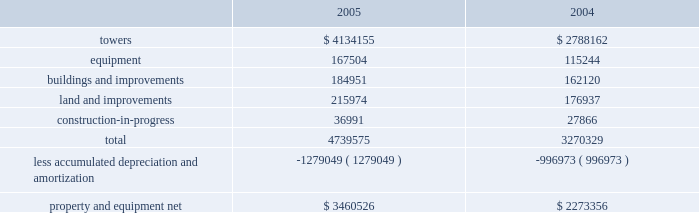American tower corporation and subsidiaries notes to consolidated financial statements 2014 ( continued ) operations , net , in the accompanying consolidated statements of operations for the year ended december 31 , 2003 .
( see note 9. ) other transactions 2014in august 2003 , the company consummated the sale of galaxy engineering ( galaxy ) , a radio frequency engineering , network design and tower-related consulting business ( previously included in the company 2019s network development services segment ) .
The purchase price of approximately $ 3.5 million included $ 2.0 million in cash , which the company received at closing , and an additional $ 1.5 million payable on january 15 , 2008 , or at an earlier date based on the future revenues of galaxy .
The company received $ 0.5 million of this amount in january 2005 .
Pursuant to this transaction , the company recorded a net loss on disposal of approximately $ 2.4 million in the accompanying consolidated statement of operations for the year ended december 31 , 2003 .
In may 2003 , the company consummated the sale of an office building in westwood , massachusetts ( previously held primarily as rental property and included in the company 2019s rental and management segment ) for a purchase price of approximately $ 18.5 million , including $ 2.4 million of cash proceeds and the buyer 2019s assumption of $ 16.1 million of related mortgage notes .
Pursuant to this transaction , the company recorded a net loss on disposal of approximately $ 3.6 million in the accompanying consolidated statement of operations for the year ended december 31 , 2003 .
In january 2003 , the company consummated the sale of flash technologies , its remaining components business ( previously included in the company 2019s network development services segment ) for approximately $ 35.5 million in cash and has recorded a net gain on disposal of approximately $ 0.1 million in the accompanying consolidated statement of operations for the year ended december 31 , 2003 .
In march 2003 , the company consummated the sale of an office building in schaumburg , illinois ( previously held primarily as rental property and included in the company 2019s rental and management segment ) for net proceeds of approximately $ 10.3 million in cash and recorded a net loss on disposal of $ 0.1 million in the accompanying consolidated statement of operations for the year ended december 31 , 2003 .
Property and equipment property and equipment ( including assets held under capital leases ) consist of the following as of december 31 , ( in thousands ) : .
Goodwill and other intangible assets the company 2019s net carrying amount of goodwill was approximately $ 2.1 billion as of december 312005 and $ 592.7 million as of december 31 , 2004 , all of which related to its rental and management segment .
The increase in the carrying value was as a result of the goodwill of $ 1.5 billion acquired in the merger with spectrasite , inc .
( see note 2. ) .
What is the percentage change in the balance of total property and equipment from 2004 to 2005? 
Computations: ((4739575 - 3270329) / 3270329)
Answer: 0.44927. American tower corporation and subsidiaries notes to consolidated financial statements 2014 ( continued ) operations , net , in the accompanying consolidated statements of operations for the year ended december 31 , 2003 .
( see note 9. ) other transactions 2014in august 2003 , the company consummated the sale of galaxy engineering ( galaxy ) , a radio frequency engineering , network design and tower-related consulting business ( previously included in the company 2019s network development services segment ) .
The purchase price of approximately $ 3.5 million included $ 2.0 million in cash , which the company received at closing , and an additional $ 1.5 million payable on january 15 , 2008 , or at an earlier date based on the future revenues of galaxy .
The company received $ 0.5 million of this amount in january 2005 .
Pursuant to this transaction , the company recorded a net loss on disposal of approximately $ 2.4 million in the accompanying consolidated statement of operations for the year ended december 31 , 2003 .
In may 2003 , the company consummated the sale of an office building in westwood , massachusetts ( previously held primarily as rental property and included in the company 2019s rental and management segment ) for a purchase price of approximately $ 18.5 million , including $ 2.4 million of cash proceeds and the buyer 2019s assumption of $ 16.1 million of related mortgage notes .
Pursuant to this transaction , the company recorded a net loss on disposal of approximately $ 3.6 million in the accompanying consolidated statement of operations for the year ended december 31 , 2003 .
In january 2003 , the company consummated the sale of flash technologies , its remaining components business ( previously included in the company 2019s network development services segment ) for approximately $ 35.5 million in cash and has recorded a net gain on disposal of approximately $ 0.1 million in the accompanying consolidated statement of operations for the year ended december 31 , 2003 .
In march 2003 , the company consummated the sale of an office building in schaumburg , illinois ( previously held primarily as rental property and included in the company 2019s rental and management segment ) for net proceeds of approximately $ 10.3 million in cash and recorded a net loss on disposal of $ 0.1 million in the accompanying consolidated statement of operations for the year ended december 31 , 2003 .
Property and equipment property and equipment ( including assets held under capital leases ) consist of the following as of december 31 , ( in thousands ) : .
Goodwill and other intangible assets the company 2019s net carrying amount of goodwill was approximately $ 2.1 billion as of december 312005 and $ 592.7 million as of december 31 , 2004 , all of which related to its rental and management segment .
The increase in the carrying value was as a result of the goodwill of $ 1.5 billion acquired in the merger with spectrasite , inc .
( see note 2. ) .
What was the percentage increase in the property and equipment net from 2004 to 2005? 
Computations: ((3460526 - 2273356) / 2273356)
Answer: 0.52221. 